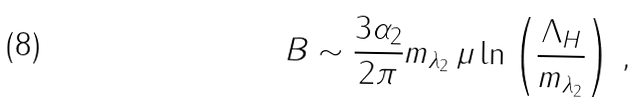Convert formula to latex. <formula><loc_0><loc_0><loc_500><loc_500>B \sim \frac { 3 \alpha _ { 2 } } { 2 \pi } m _ { \lambda _ { 2 } } \, \mu \ln \left ( \frac { \Lambda _ { H } } { m _ { \lambda _ { 2 } } } \right ) \, ,</formula> 